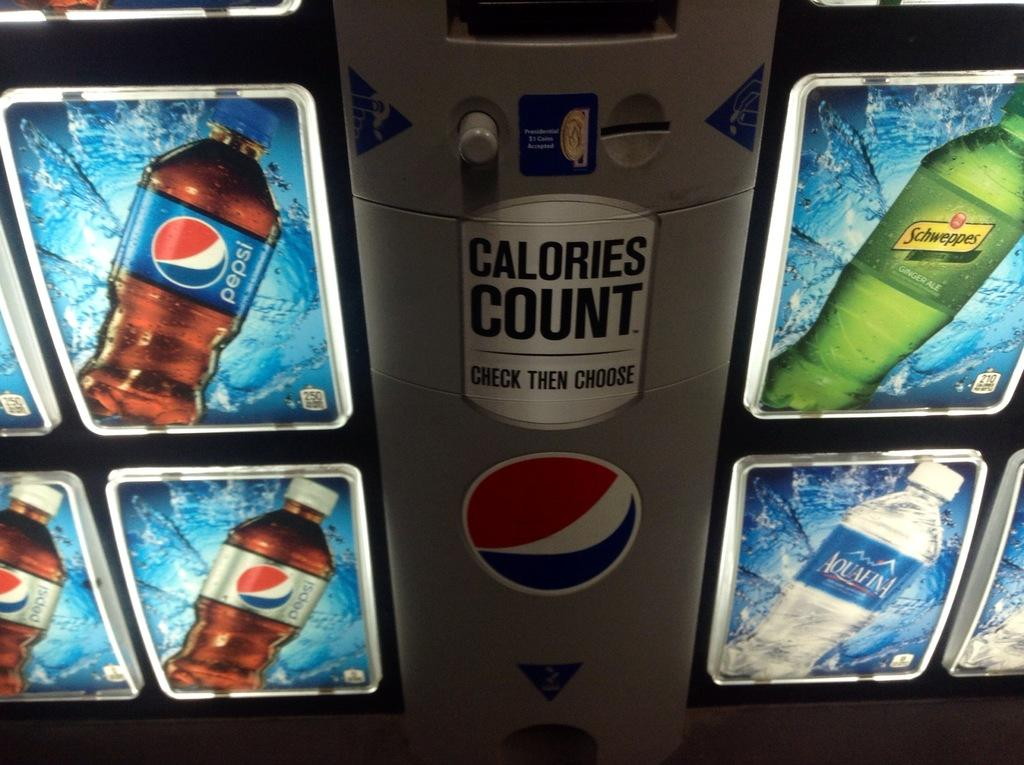<image>
Summarize the visual content of the image. The vending machine has Pepsi, Schweppes, and Aquafina. 